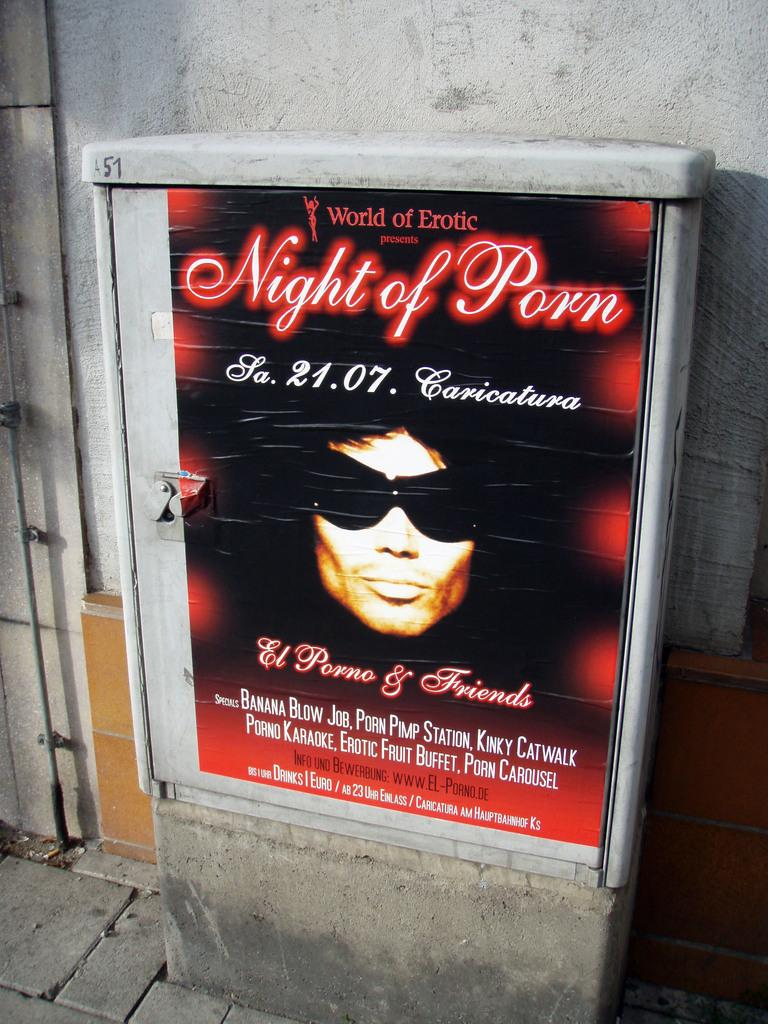<image>
Summarize the visual content of the image. An advertisement for a World of Erotic featuring Banana Blow. 